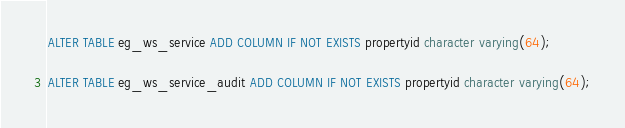<code> <loc_0><loc_0><loc_500><loc_500><_SQL_>ALTER TABLE eg_ws_service ADD COLUMN IF NOT EXISTS propertyid character varying(64);

ALTER TABLE eg_ws_service_audit ADD COLUMN IF NOT EXISTS propertyid character varying(64);</code> 